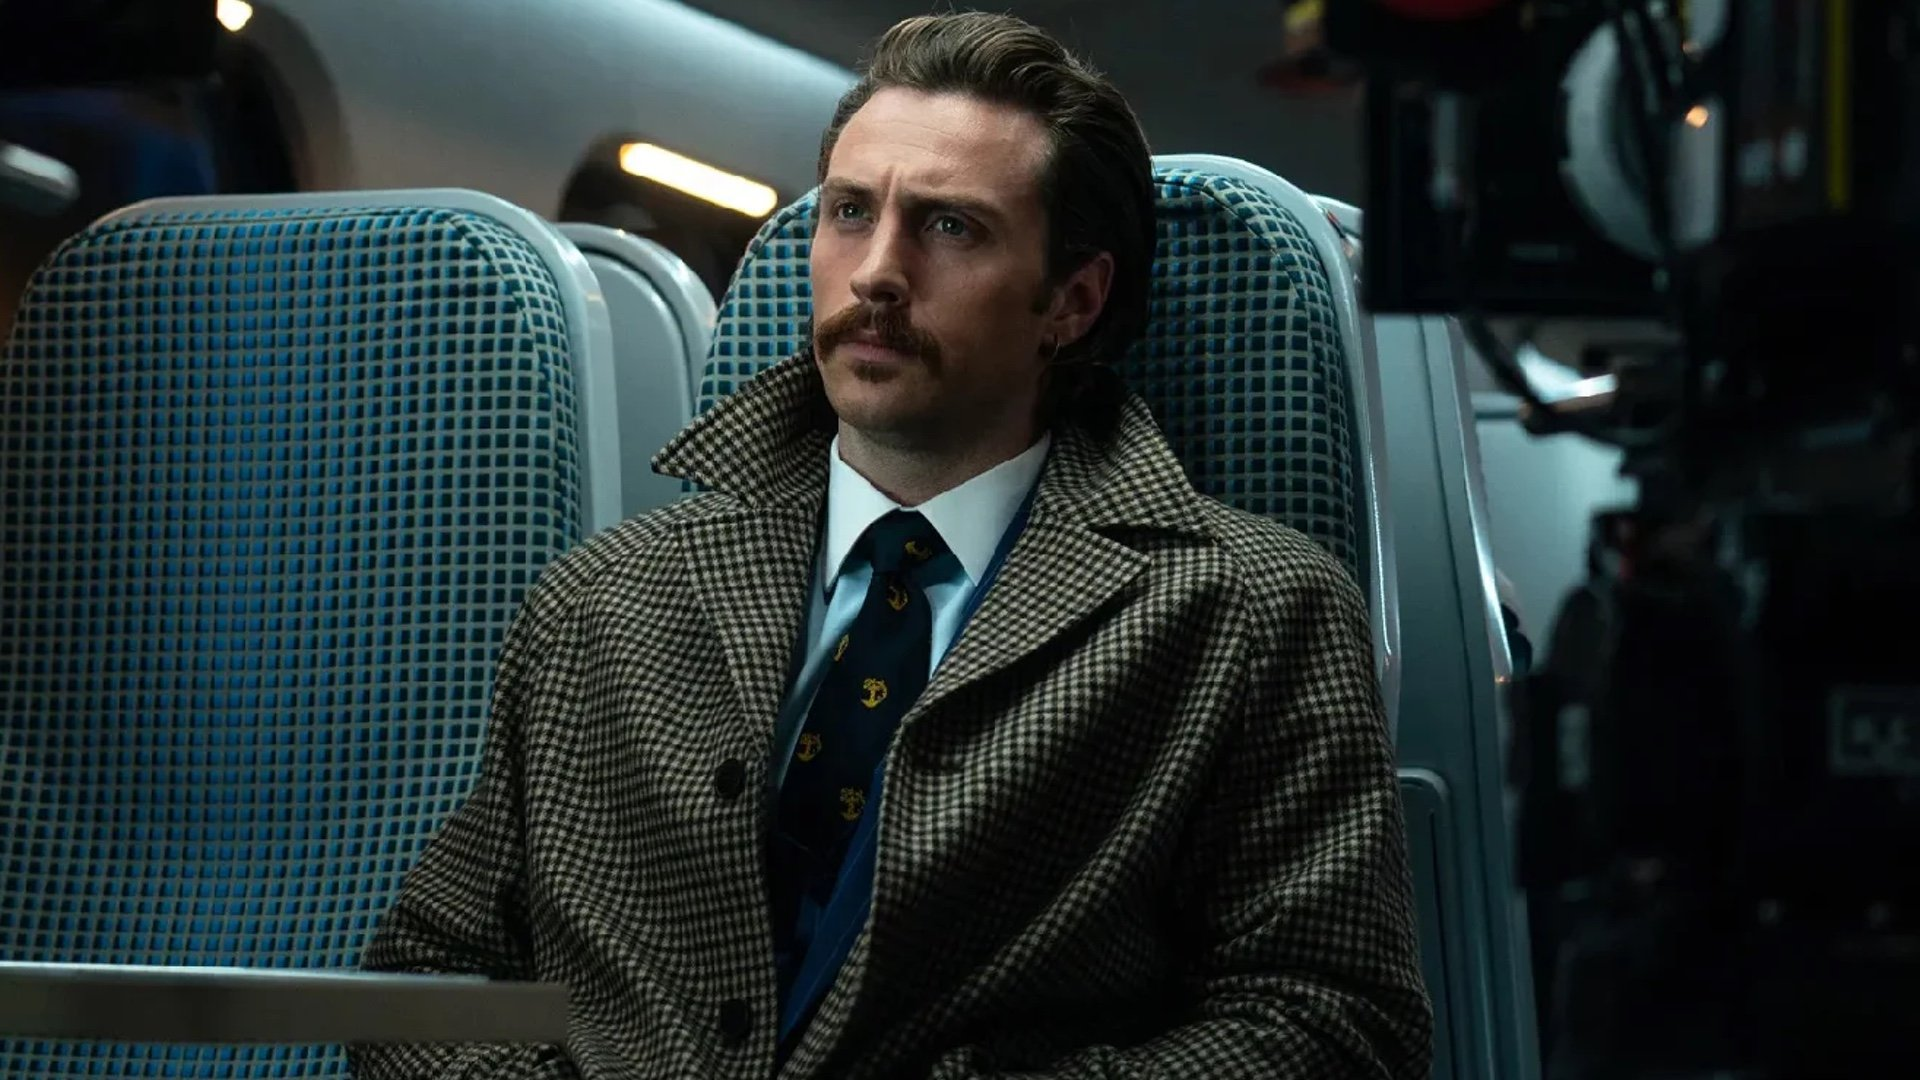How does the setting contribute to the overall mood of this scene? The train car setting, with its symmetrical seat arrangement and subdued colors, adds a sense of order and confinement. It intensifies the feeling of being trapped, both physically in the moving train and metaphorically within his circumstances, enhancing the suspenseful and contemplative mood of the scene. What does his attire say about his character? His sophisticated attire, notably the classic houndstooth coat and elegantly patterned tie, suggests a refined and perhaps complex persona. It reflects a meticulous attention to detail and a presentation that might be deliberately crafted to convey a certain image or to mask deeper insecurities and conflicts. 